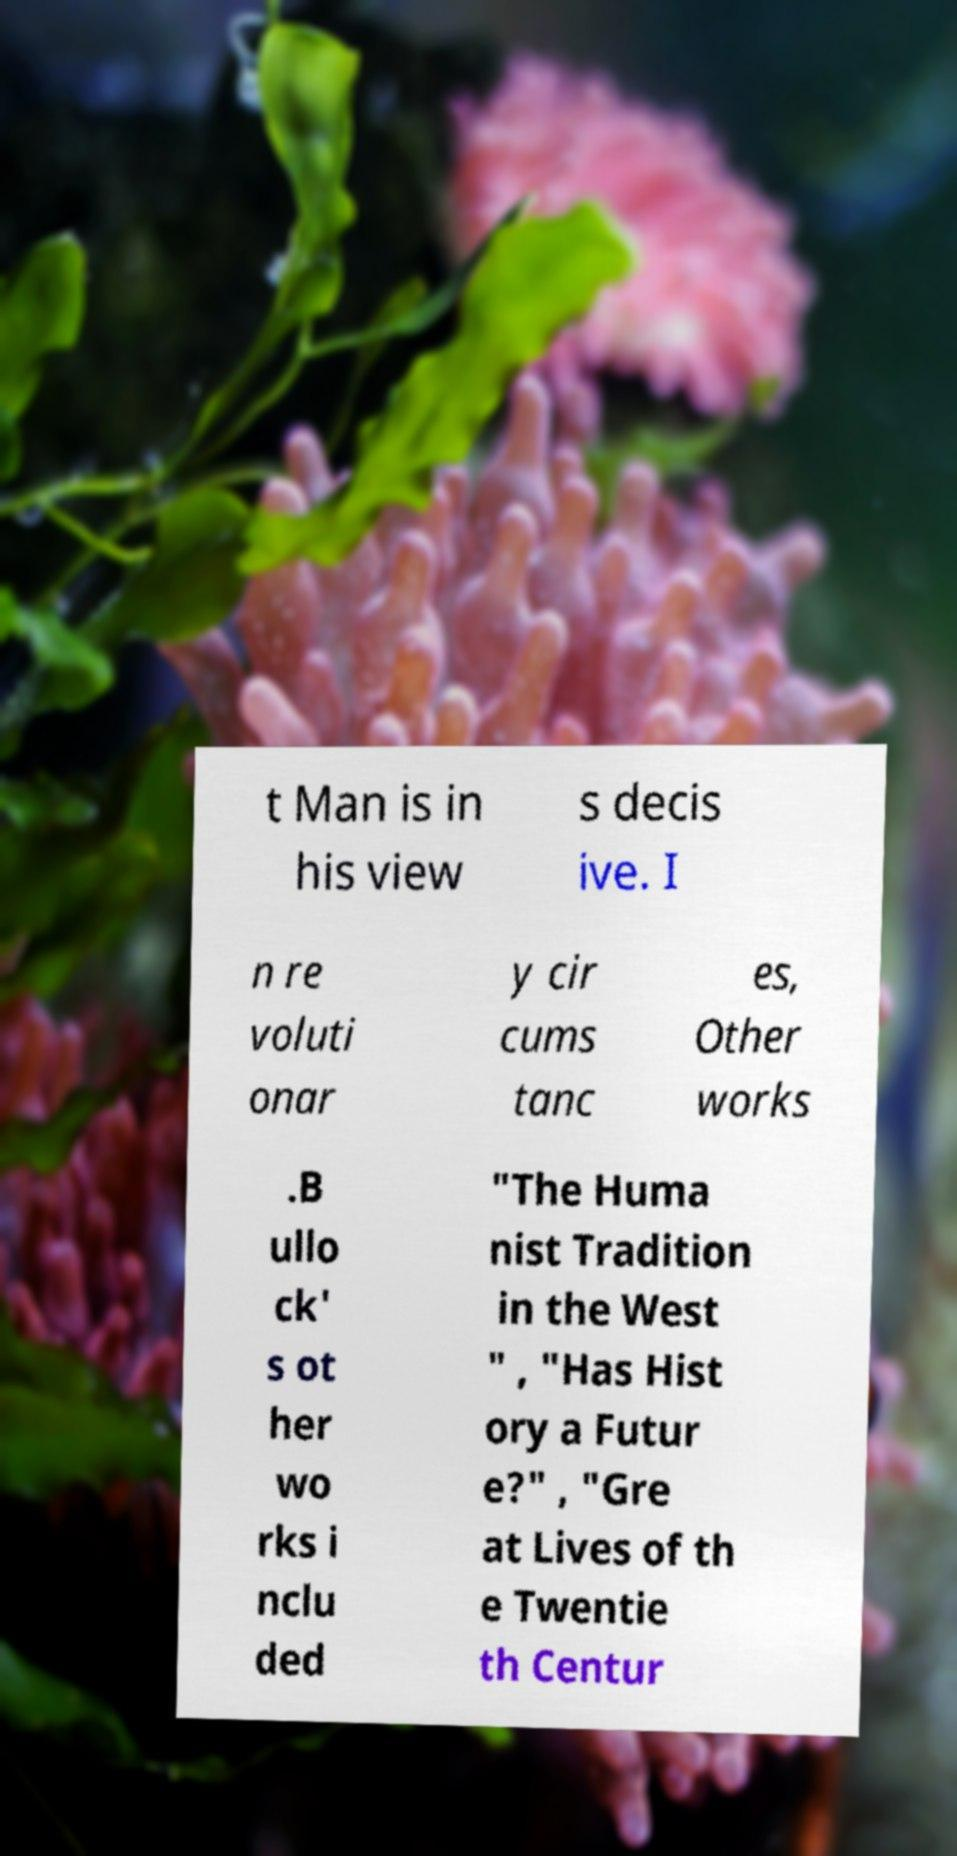Could you assist in decoding the text presented in this image and type it out clearly? t Man is in his view s decis ive. I n re voluti onar y cir cums tanc es, Other works .B ullo ck' s ot her wo rks i nclu ded "The Huma nist Tradition in the West " , "Has Hist ory a Futur e?" , "Gre at Lives of th e Twentie th Centur 